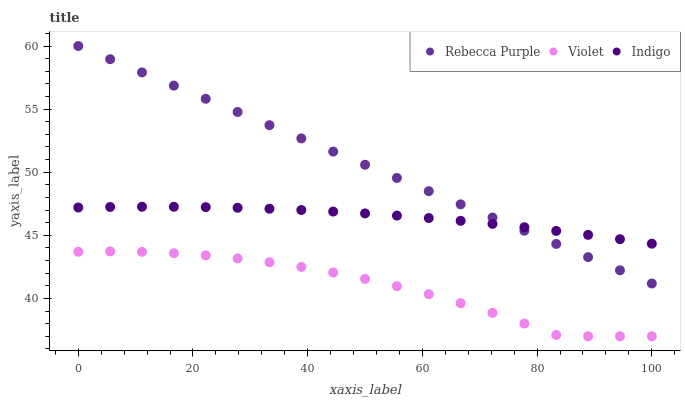Does Violet have the minimum area under the curve?
Answer yes or no. Yes. Does Rebecca Purple have the maximum area under the curve?
Answer yes or no. Yes. Does Rebecca Purple have the minimum area under the curve?
Answer yes or no. No. Does Violet have the maximum area under the curve?
Answer yes or no. No. Is Rebecca Purple the smoothest?
Answer yes or no. Yes. Is Violet the roughest?
Answer yes or no. Yes. Is Violet the smoothest?
Answer yes or no. No. Is Rebecca Purple the roughest?
Answer yes or no. No. Does Violet have the lowest value?
Answer yes or no. Yes. Does Rebecca Purple have the lowest value?
Answer yes or no. No. Does Rebecca Purple have the highest value?
Answer yes or no. Yes. Does Violet have the highest value?
Answer yes or no. No. Is Violet less than Indigo?
Answer yes or no. Yes. Is Rebecca Purple greater than Violet?
Answer yes or no. Yes. Does Indigo intersect Rebecca Purple?
Answer yes or no. Yes. Is Indigo less than Rebecca Purple?
Answer yes or no. No. Is Indigo greater than Rebecca Purple?
Answer yes or no. No. Does Violet intersect Indigo?
Answer yes or no. No. 